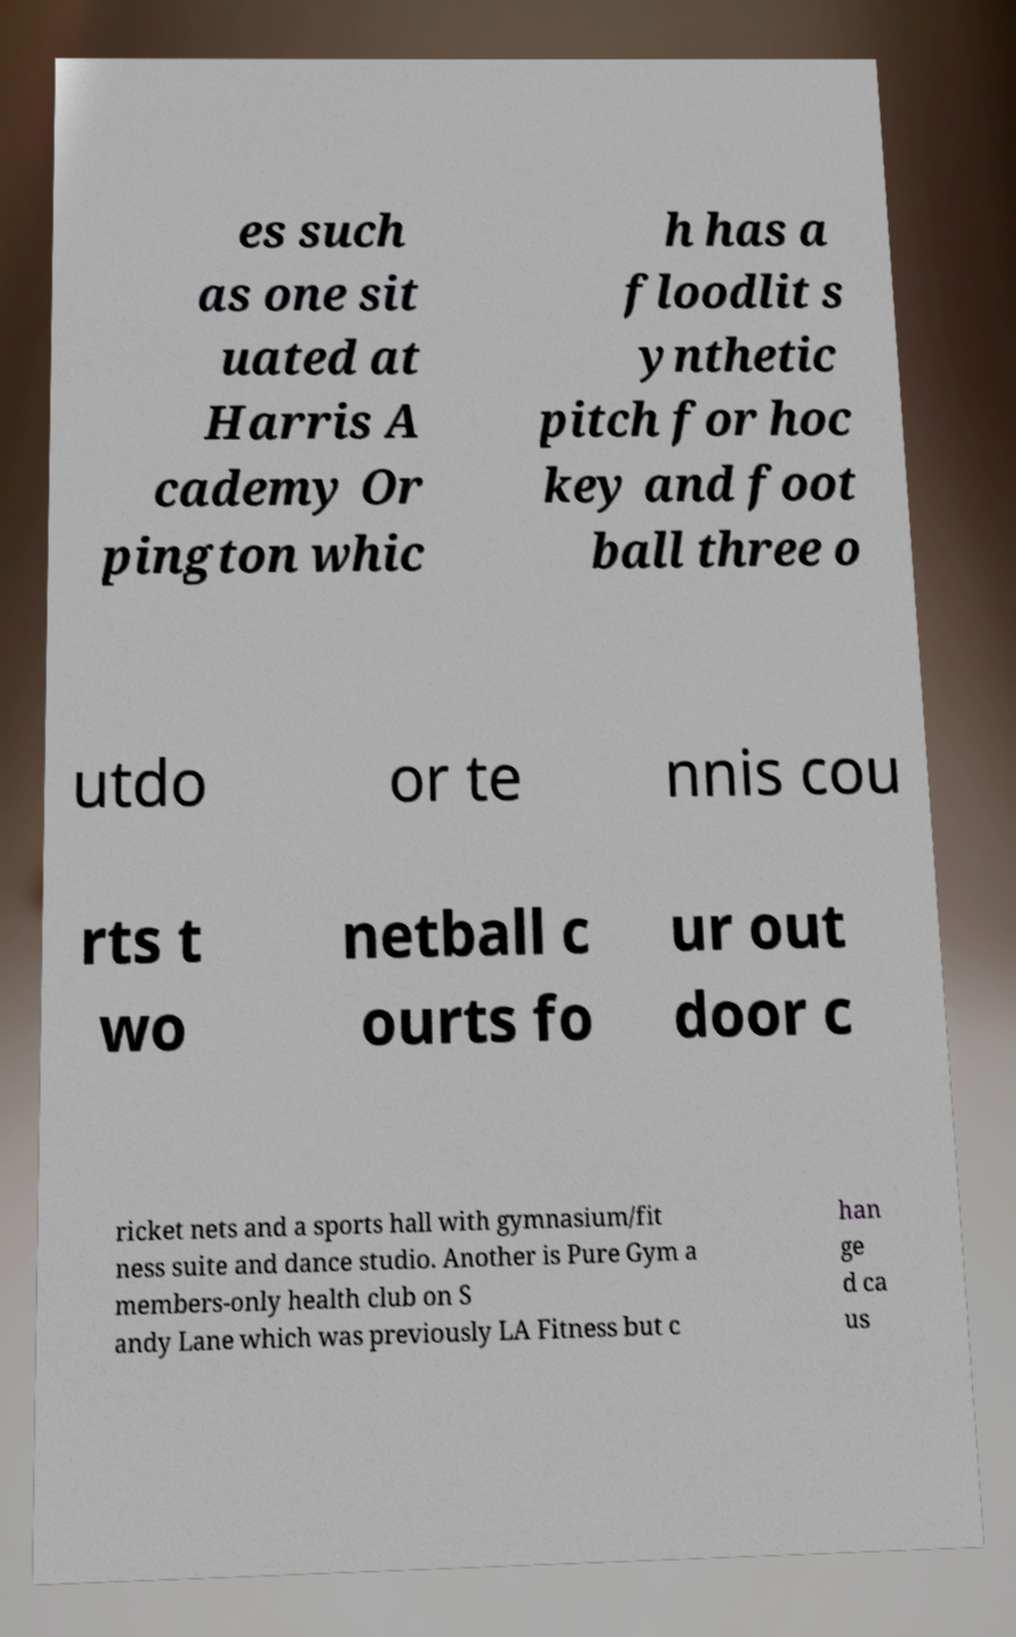I need the written content from this picture converted into text. Can you do that? es such as one sit uated at Harris A cademy Or pington whic h has a floodlit s ynthetic pitch for hoc key and foot ball three o utdo or te nnis cou rts t wo netball c ourts fo ur out door c ricket nets and a sports hall with gymnasium/fit ness suite and dance studio. Another is Pure Gym a members-only health club on S andy Lane which was previously LA Fitness but c han ge d ca us 